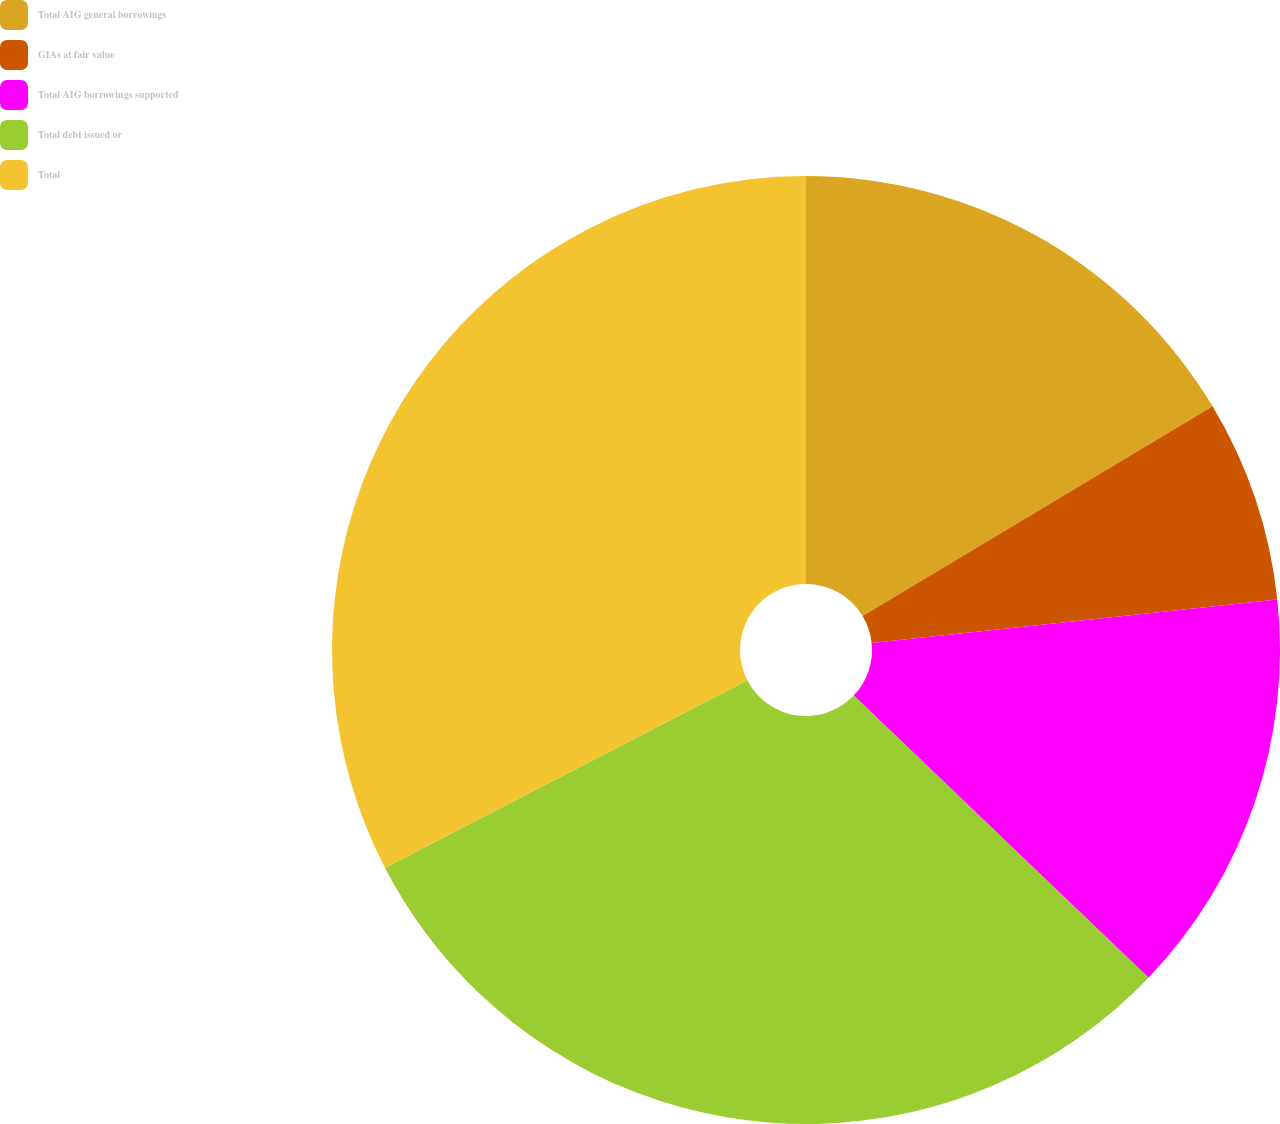Convert chart to OTSL. <chart><loc_0><loc_0><loc_500><loc_500><pie_chart><fcel>Total AIG general borrowings<fcel>GIAs at fair value<fcel>Total AIG borrowings supported<fcel>Total debt issued or<fcel>Total<nl><fcel>16.41%<fcel>6.89%<fcel>13.85%<fcel>30.26%<fcel>32.6%<nl></chart> 